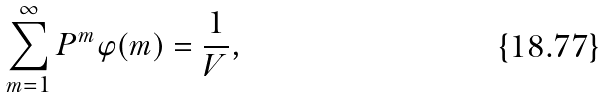Convert formula to latex. <formula><loc_0><loc_0><loc_500><loc_500>\sum _ { m = 1 } ^ { \infty } P ^ { m } \varphi ( m ) = \frac { 1 } { V } ,</formula> 